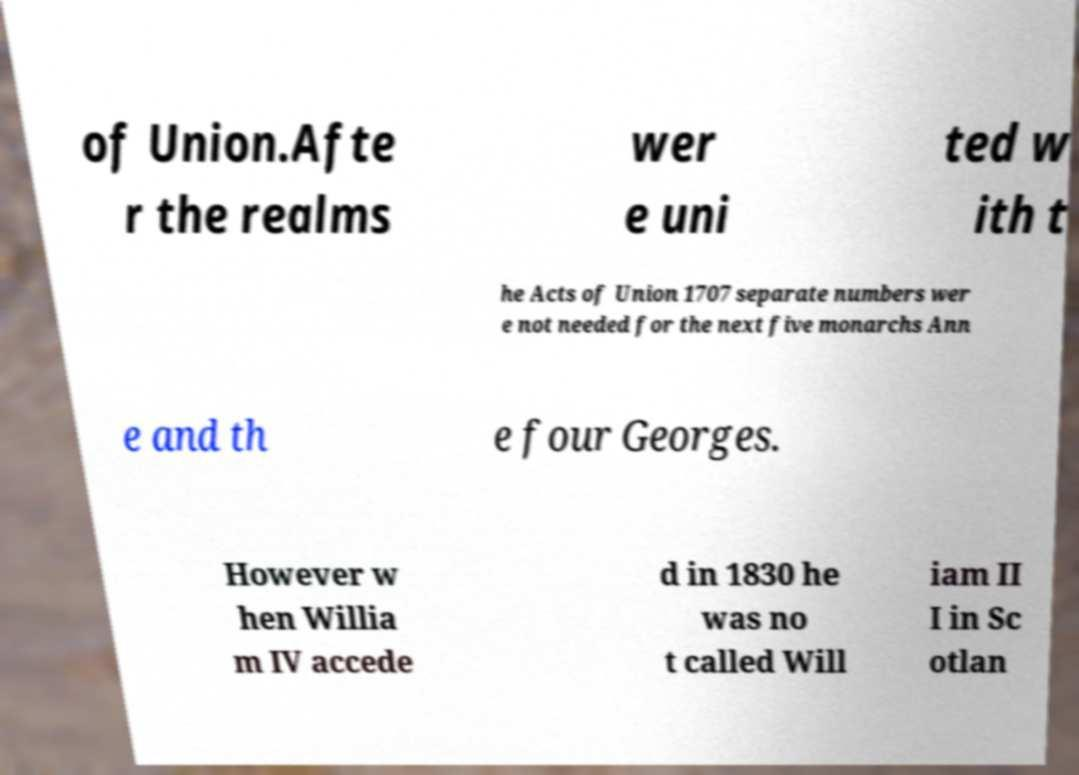I need the written content from this picture converted into text. Can you do that? of Union.Afte r the realms wer e uni ted w ith t he Acts of Union 1707 separate numbers wer e not needed for the next five monarchs Ann e and th e four Georges. However w hen Willia m IV accede d in 1830 he was no t called Will iam II I in Sc otlan 